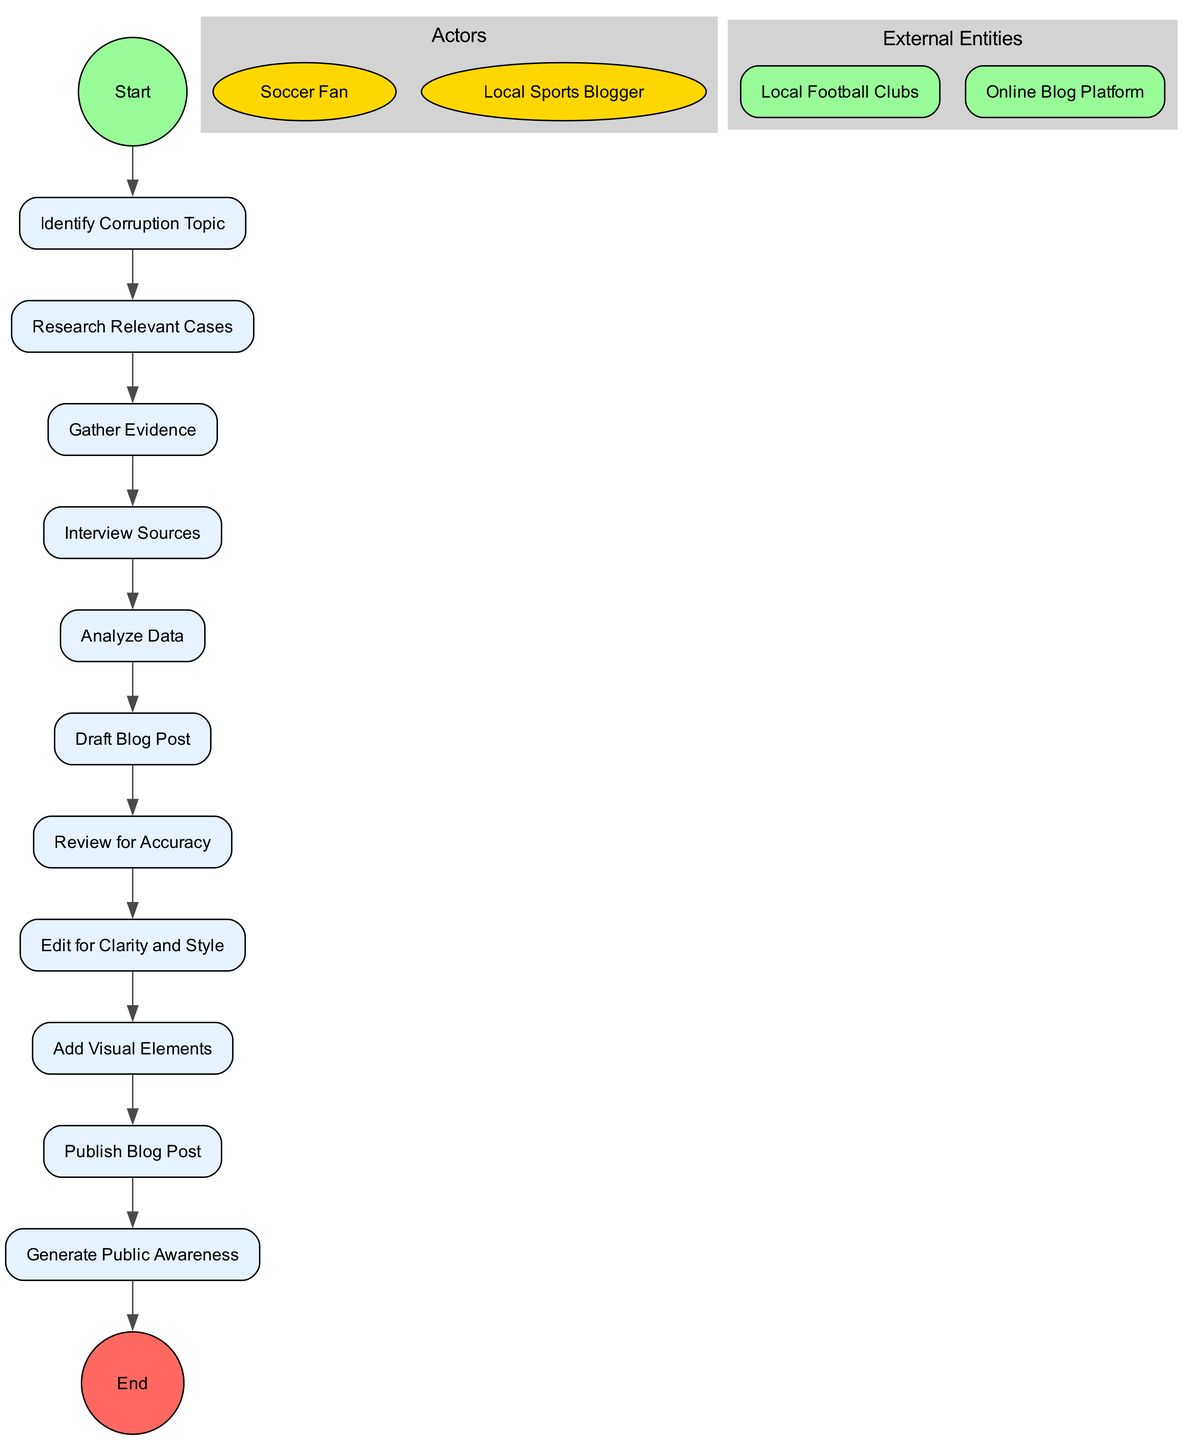What is the first action in the diagram? The first action node in the flow is "Identify Corruption Topic." It comes immediately after the starting point of the diagram.
Answer: Identify Corruption Topic How many actions are present in the diagram? Counting every action node listed in the diagram, there are a total of eleven actions that are part of the process to write and publish a blog post.
Answer: 11 What action follows "Gather Evidence"? The action that directly follows "Gather Evidence" in the sequence is "Interview Sources," indicating the next step to gather testimonials or insights.
Answer: Interview Sources Which actor is responsible for drafting the blog post? The "Local Sports Blogger" is the actor responsible for drafting the blog post, as indicated by their role in the diagram.
Answer: Local Sports Blogger What is the last action before publishing the blog post? The last action before the publishing step is "Edit for Clarity and Style," which focuses on ensuring the content is polished before it goes live.
Answer: Edit for Clarity and Style Which external entity is involved in the publishing process? The "Online Blog Platform" is identified as the external entity that is involved in the publishing process, providing the means to share the blog post with the public.
Answer: Online Blog Platform How many actors are represented in the diagram? There are two distinct actors represented in the diagram: the "Soccer Fan" and the "Local Sports Blogger."
Answer: 2 What action leads to generating public awareness? The action that leads to "Generate Public Awareness" is "Publish Blog Post," as sharing the blog post is intended to raise awareness about the corruption issues discussed.
Answer: Publish Blog Post What is the end node labeled as in the diagram? The end of the process is labeled as "End," which signifies the conclusion of the entire blogging workflow presented in the diagram.
Answer: End 